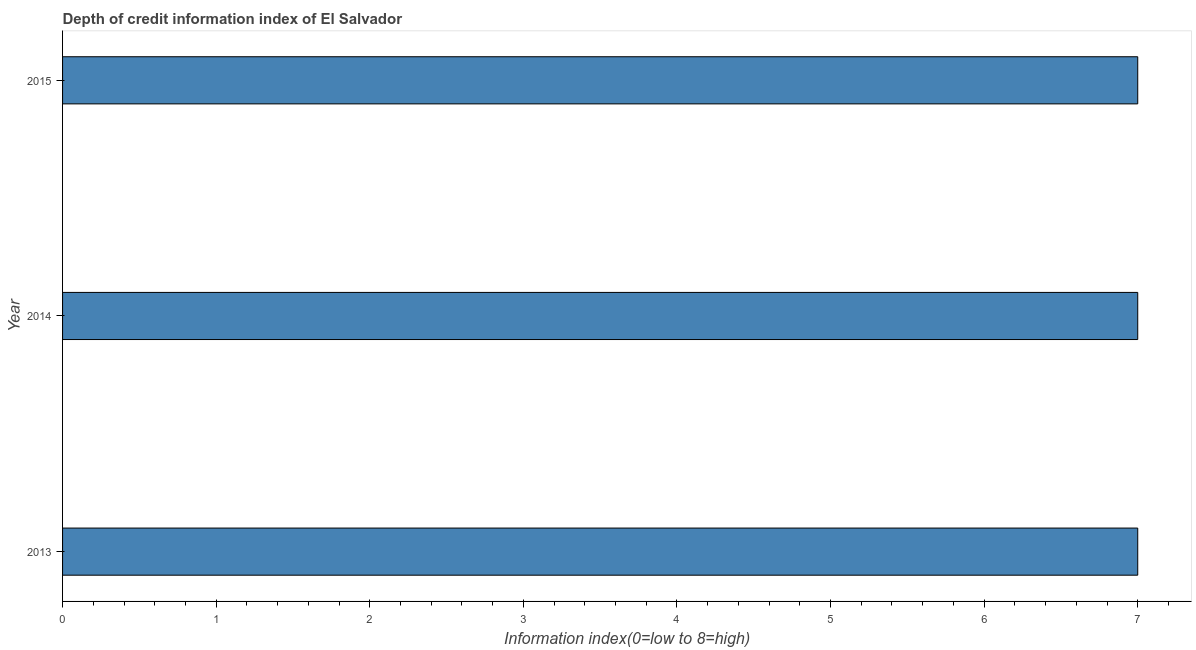Does the graph contain any zero values?
Your answer should be compact. No. What is the title of the graph?
Your response must be concise. Depth of credit information index of El Salvador. What is the label or title of the X-axis?
Your answer should be very brief. Information index(0=low to 8=high). What is the depth of credit information index in 2015?
Offer a terse response. 7. Across all years, what is the maximum depth of credit information index?
Provide a succinct answer. 7. Across all years, what is the minimum depth of credit information index?
Ensure brevity in your answer.  7. In which year was the depth of credit information index maximum?
Provide a succinct answer. 2013. In which year was the depth of credit information index minimum?
Your response must be concise. 2013. What is the ratio of the depth of credit information index in 2013 to that in 2014?
Offer a very short reply. 1. What is the Information index(0=low to 8=high) in 2013?
Provide a short and direct response. 7. What is the difference between the Information index(0=low to 8=high) in 2013 and 2015?
Keep it short and to the point. 0. What is the ratio of the Information index(0=low to 8=high) in 2013 to that in 2014?
Make the answer very short. 1. 